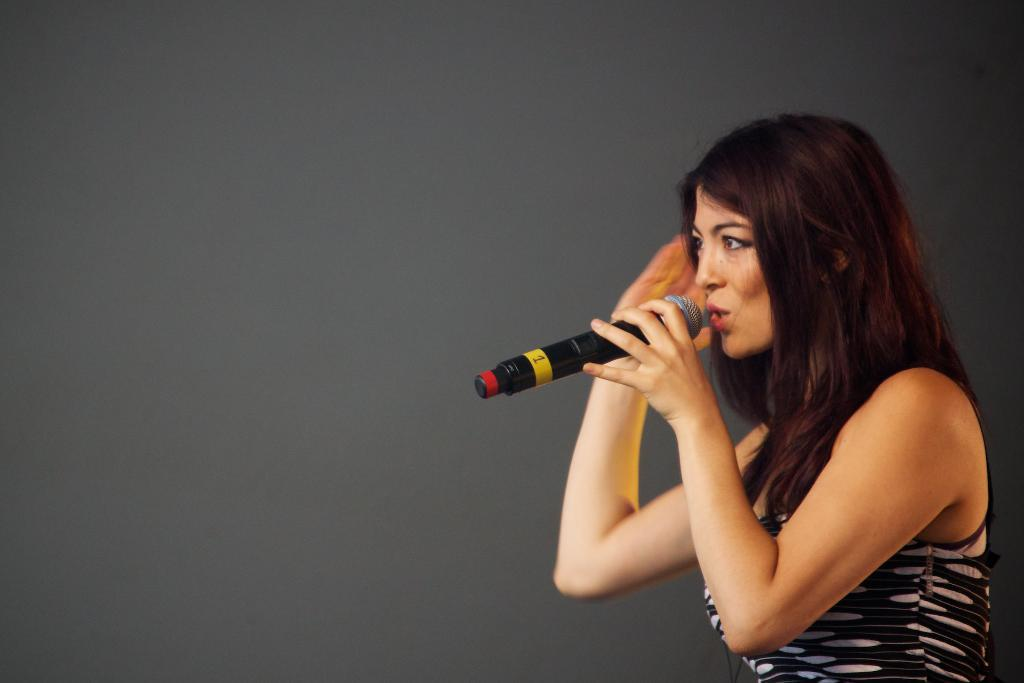What is the woman doing in the image? She is standing and holding a microphone. What is she doing with the microphone? She is speaking into the microphone. Can you describe her facial expression or action while speaking? Her mouth is open while she is speaking. What type of star can be seen falling from the sky in the image? There is no star or sky visible in the image; it only shows a woman standing and holding a microphone. 